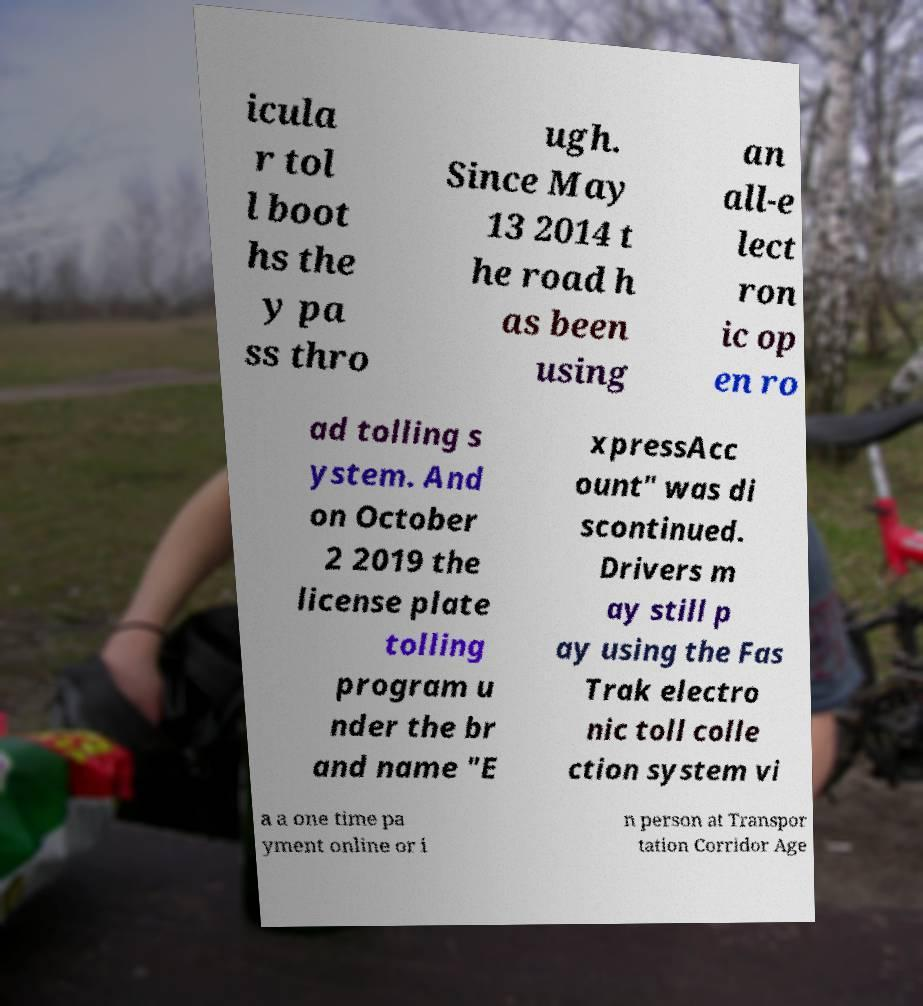What messages or text are displayed in this image? I need them in a readable, typed format. icula r tol l boot hs the y pa ss thro ugh. Since May 13 2014 t he road h as been using an all-e lect ron ic op en ro ad tolling s ystem. And on October 2 2019 the license plate tolling program u nder the br and name "E xpressAcc ount" was di scontinued. Drivers m ay still p ay using the Fas Trak electro nic toll colle ction system vi a a one time pa yment online or i n person at Transpor tation Corridor Age 